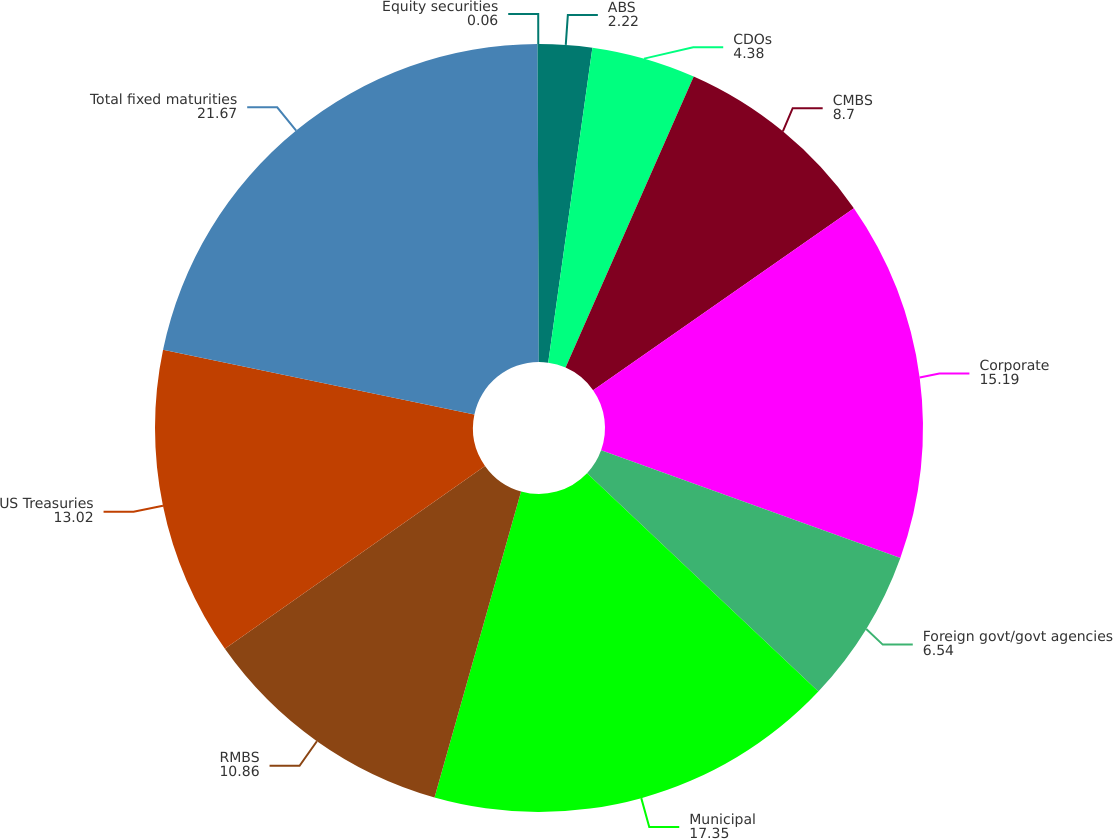<chart> <loc_0><loc_0><loc_500><loc_500><pie_chart><fcel>ABS<fcel>CDOs<fcel>CMBS<fcel>Corporate<fcel>Foreign govt/govt agencies<fcel>Municipal<fcel>RMBS<fcel>US Treasuries<fcel>Total fixed maturities<fcel>Equity securities<nl><fcel>2.22%<fcel>4.38%<fcel>8.7%<fcel>15.19%<fcel>6.54%<fcel>17.35%<fcel>10.86%<fcel>13.02%<fcel>21.67%<fcel>0.06%<nl></chart> 